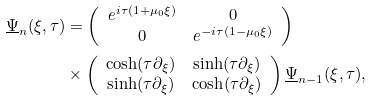Convert formula to latex. <formula><loc_0><loc_0><loc_500><loc_500>\underline { \Psi } _ { n } ( \xi , \tau ) & = \left ( \begin{array} { c c } e ^ { i \tau ( 1 + \mu _ { 0 } \xi ) } & 0 \\ 0 & e ^ { - i \tau ( 1 - \mu _ { 0 } \xi ) } \end{array} \right ) \\ & \times \left ( \begin{array} { c c } \cosh ( \tau \partial _ { \xi } ) & \sinh ( \tau \partial _ { \xi } ) \\ \sinh ( \tau \partial _ { \xi } ) & \cosh ( \tau \partial _ { \xi } ) \end{array} \right ) \underline { \Psi } _ { n - 1 } ( \xi , \tau ) ,</formula> 